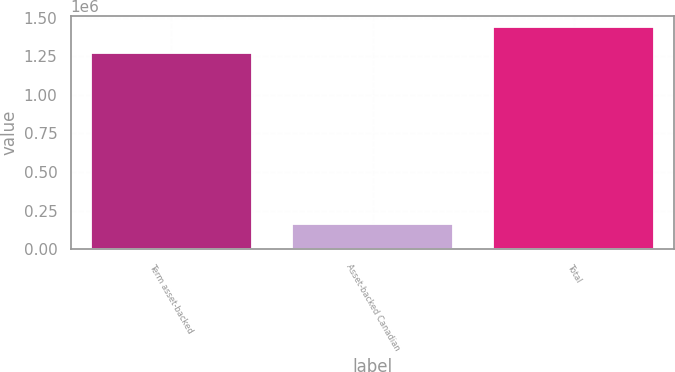<chart> <loc_0><loc_0><loc_500><loc_500><bar_chart><fcel>Term asset-backed<fcel>Asset-backed Canadian<fcel>Total<nl><fcel>1.27153e+06<fcel>166912<fcel>1.43844e+06<nl></chart> 